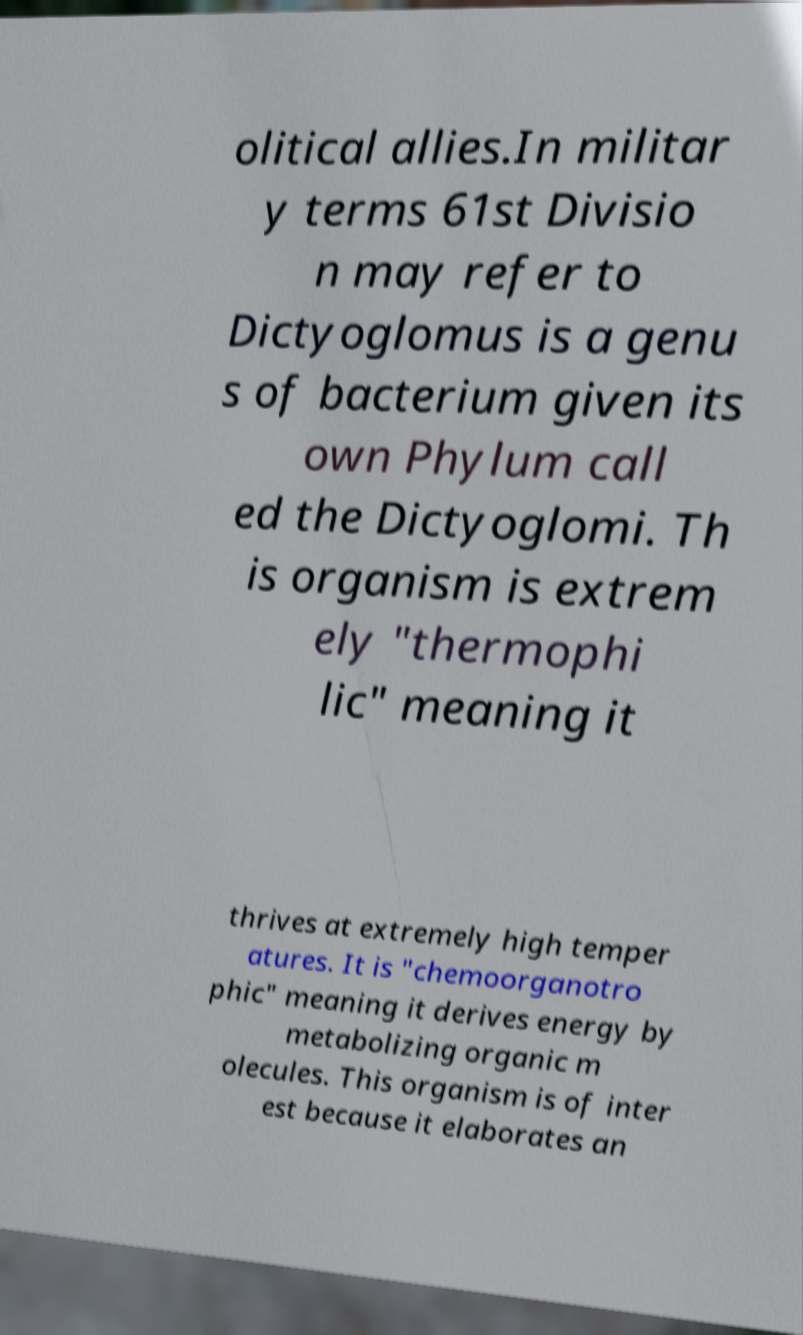I need the written content from this picture converted into text. Can you do that? olitical allies.In militar y terms 61st Divisio n may refer to Dictyoglomus is a genu s of bacterium given its own Phylum call ed the Dictyoglomi. Th is organism is extrem ely "thermophi lic" meaning it thrives at extremely high temper atures. It is "chemoorganotro phic" meaning it derives energy by metabolizing organic m olecules. This organism is of inter est because it elaborates an 